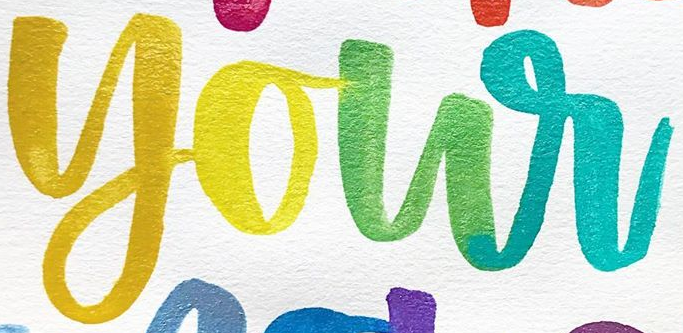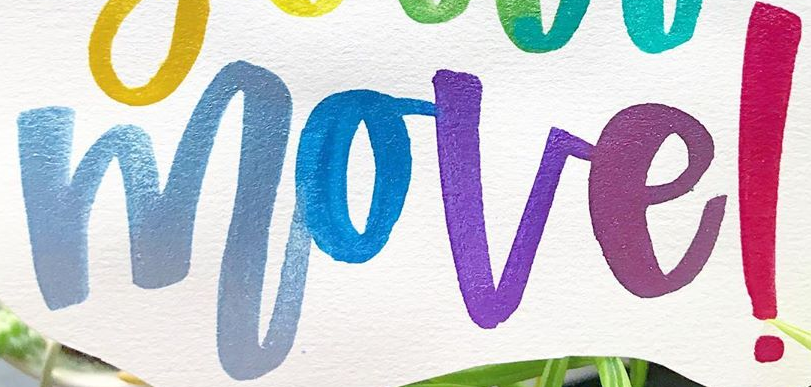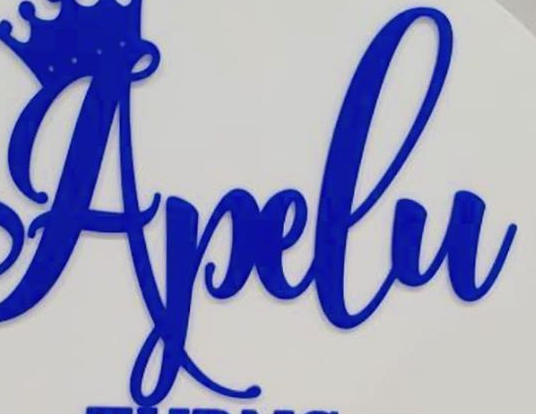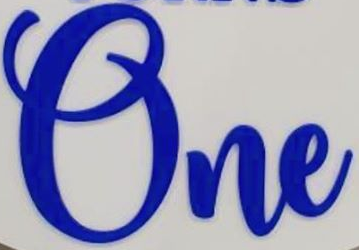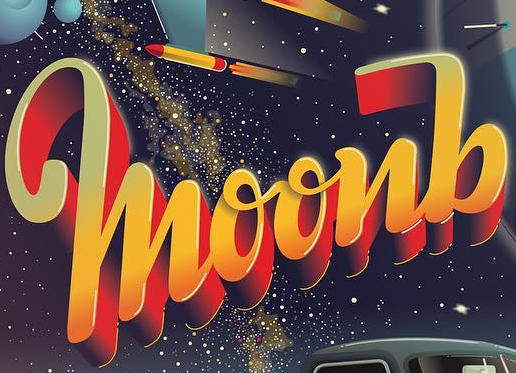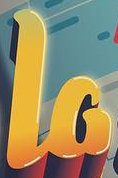Identify the words shown in these images in order, separated by a semicolon. your; move!; Apelu; One; moonb; la 